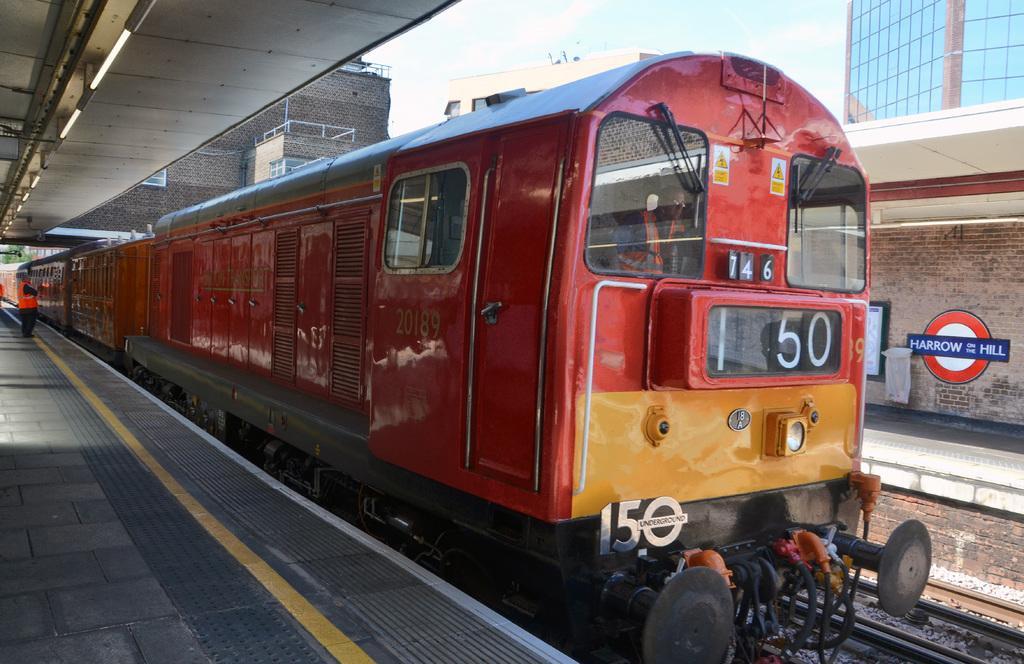How would you summarize this image in a sentence or two? This image is clicked at a railway station. In the center there is a train on the railway track. There are numbers on the train. On the either sides of the train there are platforms. To the left there is a person standing on the platform. There is a shed on the platform. To the right there is text on the wall of the platform. In the background of buildings and the sky. 